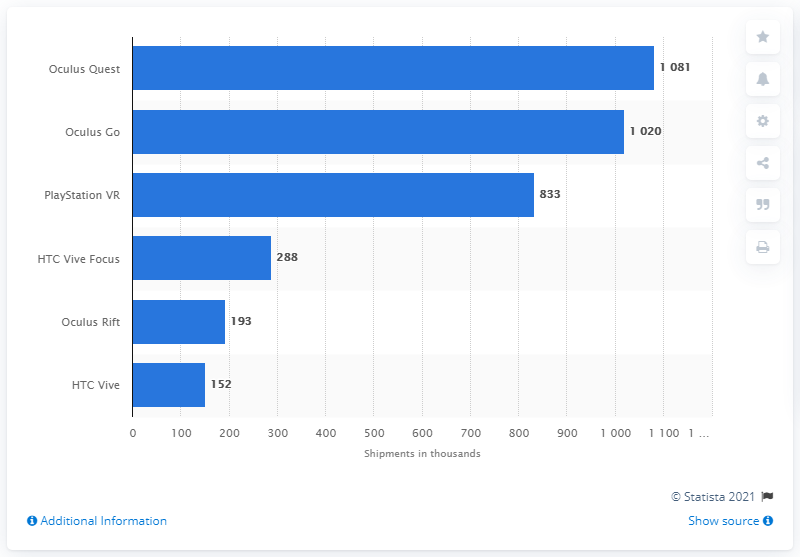Outline some significant characteristics in this image. It is expected that the Oculus Quest will be the best-selling VR headset in 2019. 